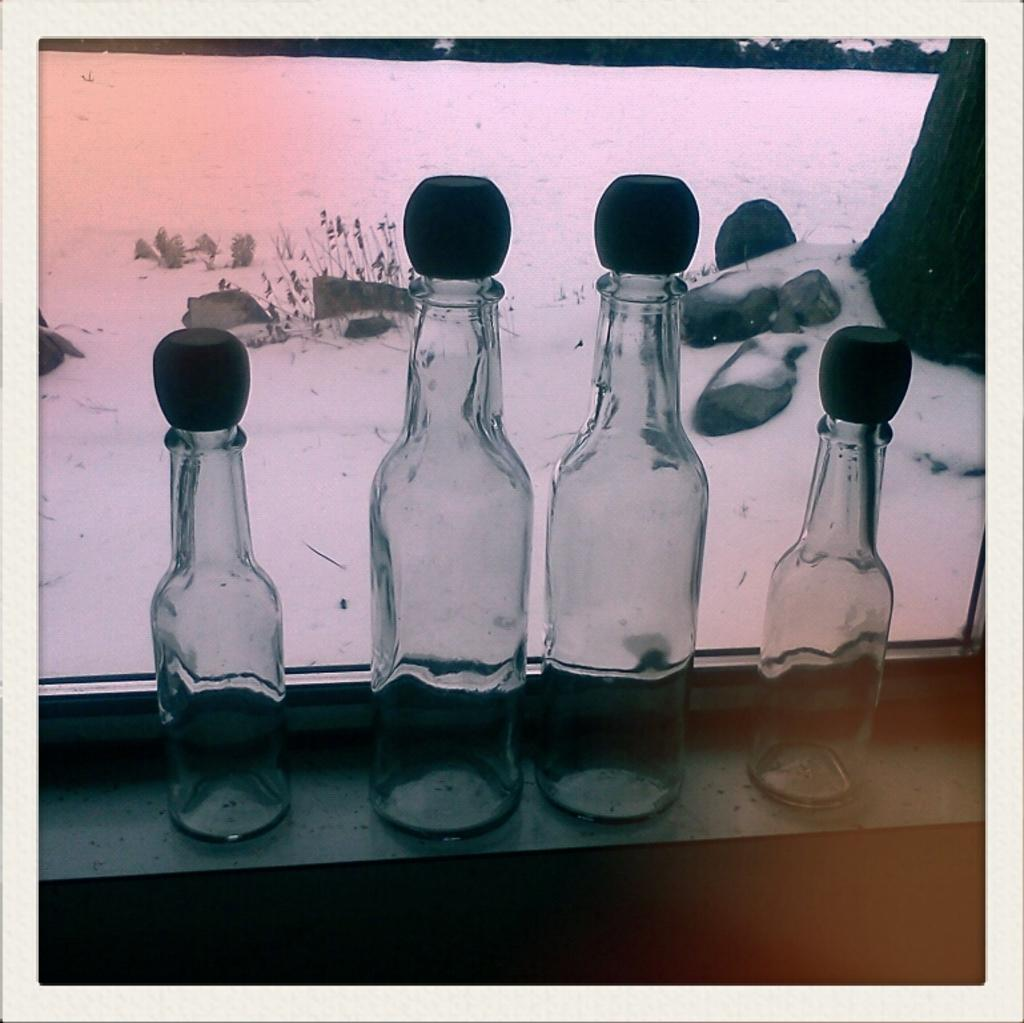How many bottles are visible in the image? There are four bottles in the image. Are the bottles all the same size? No, the bottles come in two different sizes. Where are the bottles located in the image? The bottles are placed on a table. What can be seen in the background of the image? There is snow on the rocks in the background of the image. How many letters are written on the largest bottle in the image? There are no letters written on any of the bottles in the image. Are there any giants visible in the image? There are no giants present in the image. 